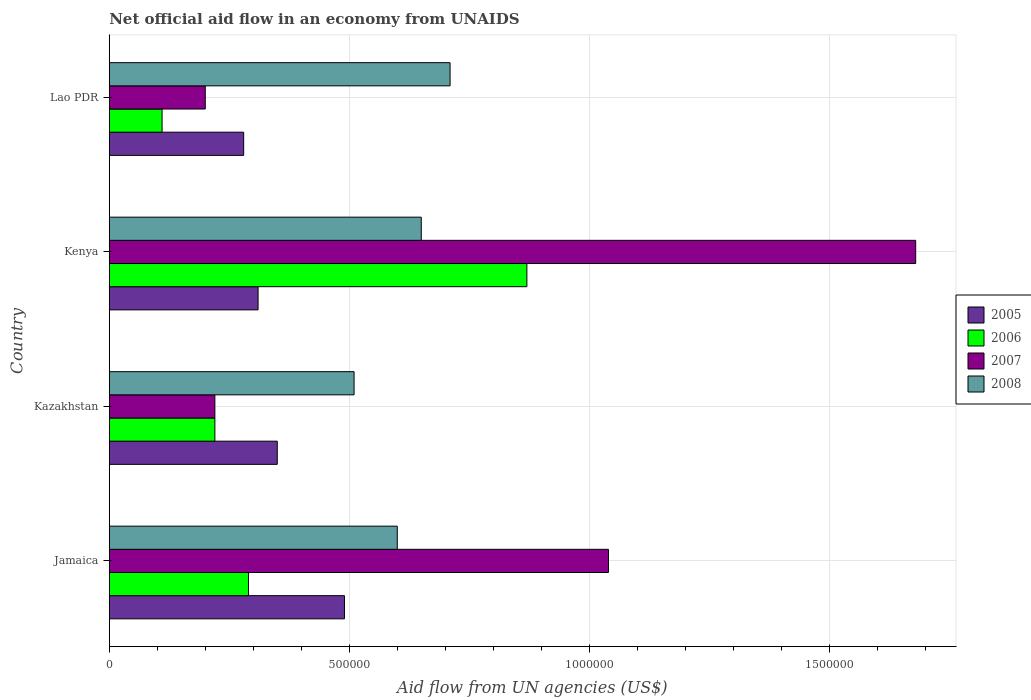What is the label of the 3rd group of bars from the top?
Your answer should be compact. Kazakhstan. In how many cases, is the number of bars for a given country not equal to the number of legend labels?
Make the answer very short. 0. What is the net official aid flow in 2005 in Kazakhstan?
Offer a terse response. 3.50e+05. Across all countries, what is the maximum net official aid flow in 2006?
Your answer should be very brief. 8.70e+05. In which country was the net official aid flow in 2005 maximum?
Your answer should be compact. Jamaica. In which country was the net official aid flow in 2007 minimum?
Provide a succinct answer. Lao PDR. What is the total net official aid flow in 2006 in the graph?
Give a very brief answer. 1.49e+06. What is the difference between the net official aid flow in 2005 in Kazakhstan and the net official aid flow in 2008 in Lao PDR?
Your answer should be compact. -3.60e+05. What is the average net official aid flow in 2005 per country?
Your response must be concise. 3.58e+05. What is the ratio of the net official aid flow in 2006 in Kenya to that in Lao PDR?
Provide a short and direct response. 7.91. What is the difference between the highest and the lowest net official aid flow in 2006?
Make the answer very short. 7.60e+05. In how many countries, is the net official aid flow in 2007 greater than the average net official aid flow in 2007 taken over all countries?
Make the answer very short. 2. Is it the case that in every country, the sum of the net official aid flow in 2006 and net official aid flow in 2007 is greater than the sum of net official aid flow in 2005 and net official aid flow in 2008?
Provide a succinct answer. No. Is it the case that in every country, the sum of the net official aid flow in 2007 and net official aid flow in 2005 is greater than the net official aid flow in 2008?
Offer a terse response. No. Does the graph contain any zero values?
Your answer should be compact. No. Where does the legend appear in the graph?
Ensure brevity in your answer.  Center right. How many legend labels are there?
Provide a short and direct response. 4. What is the title of the graph?
Give a very brief answer. Net official aid flow in an economy from UNAIDS. Does "1975" appear as one of the legend labels in the graph?
Make the answer very short. No. What is the label or title of the X-axis?
Offer a terse response. Aid flow from UN agencies (US$). What is the Aid flow from UN agencies (US$) of 2006 in Jamaica?
Your answer should be very brief. 2.90e+05. What is the Aid flow from UN agencies (US$) in 2007 in Jamaica?
Offer a very short reply. 1.04e+06. What is the Aid flow from UN agencies (US$) of 2008 in Jamaica?
Your answer should be compact. 6.00e+05. What is the Aid flow from UN agencies (US$) in 2005 in Kazakhstan?
Offer a terse response. 3.50e+05. What is the Aid flow from UN agencies (US$) in 2007 in Kazakhstan?
Offer a terse response. 2.20e+05. What is the Aid flow from UN agencies (US$) in 2008 in Kazakhstan?
Your answer should be very brief. 5.10e+05. What is the Aid flow from UN agencies (US$) in 2006 in Kenya?
Ensure brevity in your answer.  8.70e+05. What is the Aid flow from UN agencies (US$) in 2007 in Kenya?
Give a very brief answer. 1.68e+06. What is the Aid flow from UN agencies (US$) of 2008 in Kenya?
Your response must be concise. 6.50e+05. What is the Aid flow from UN agencies (US$) of 2007 in Lao PDR?
Offer a very short reply. 2.00e+05. What is the Aid flow from UN agencies (US$) in 2008 in Lao PDR?
Give a very brief answer. 7.10e+05. Across all countries, what is the maximum Aid flow from UN agencies (US$) of 2005?
Give a very brief answer. 4.90e+05. Across all countries, what is the maximum Aid flow from UN agencies (US$) of 2006?
Give a very brief answer. 8.70e+05. Across all countries, what is the maximum Aid flow from UN agencies (US$) in 2007?
Keep it short and to the point. 1.68e+06. Across all countries, what is the maximum Aid flow from UN agencies (US$) of 2008?
Give a very brief answer. 7.10e+05. Across all countries, what is the minimum Aid flow from UN agencies (US$) of 2005?
Make the answer very short. 2.80e+05. Across all countries, what is the minimum Aid flow from UN agencies (US$) of 2007?
Make the answer very short. 2.00e+05. Across all countries, what is the minimum Aid flow from UN agencies (US$) of 2008?
Your answer should be compact. 5.10e+05. What is the total Aid flow from UN agencies (US$) of 2005 in the graph?
Your response must be concise. 1.43e+06. What is the total Aid flow from UN agencies (US$) in 2006 in the graph?
Your response must be concise. 1.49e+06. What is the total Aid flow from UN agencies (US$) of 2007 in the graph?
Your answer should be very brief. 3.14e+06. What is the total Aid flow from UN agencies (US$) in 2008 in the graph?
Provide a short and direct response. 2.47e+06. What is the difference between the Aid flow from UN agencies (US$) of 2005 in Jamaica and that in Kazakhstan?
Offer a very short reply. 1.40e+05. What is the difference between the Aid flow from UN agencies (US$) in 2006 in Jamaica and that in Kazakhstan?
Ensure brevity in your answer.  7.00e+04. What is the difference between the Aid flow from UN agencies (US$) of 2007 in Jamaica and that in Kazakhstan?
Offer a very short reply. 8.20e+05. What is the difference between the Aid flow from UN agencies (US$) in 2008 in Jamaica and that in Kazakhstan?
Your answer should be compact. 9.00e+04. What is the difference between the Aid flow from UN agencies (US$) of 2005 in Jamaica and that in Kenya?
Provide a short and direct response. 1.80e+05. What is the difference between the Aid flow from UN agencies (US$) in 2006 in Jamaica and that in Kenya?
Offer a terse response. -5.80e+05. What is the difference between the Aid flow from UN agencies (US$) in 2007 in Jamaica and that in Kenya?
Give a very brief answer. -6.40e+05. What is the difference between the Aid flow from UN agencies (US$) of 2008 in Jamaica and that in Kenya?
Your answer should be compact. -5.00e+04. What is the difference between the Aid flow from UN agencies (US$) in 2005 in Jamaica and that in Lao PDR?
Ensure brevity in your answer.  2.10e+05. What is the difference between the Aid flow from UN agencies (US$) of 2006 in Jamaica and that in Lao PDR?
Provide a short and direct response. 1.80e+05. What is the difference between the Aid flow from UN agencies (US$) in 2007 in Jamaica and that in Lao PDR?
Provide a short and direct response. 8.40e+05. What is the difference between the Aid flow from UN agencies (US$) of 2008 in Jamaica and that in Lao PDR?
Provide a succinct answer. -1.10e+05. What is the difference between the Aid flow from UN agencies (US$) of 2006 in Kazakhstan and that in Kenya?
Make the answer very short. -6.50e+05. What is the difference between the Aid flow from UN agencies (US$) in 2007 in Kazakhstan and that in Kenya?
Provide a short and direct response. -1.46e+06. What is the difference between the Aid flow from UN agencies (US$) in 2008 in Kazakhstan and that in Kenya?
Offer a terse response. -1.40e+05. What is the difference between the Aid flow from UN agencies (US$) of 2006 in Kazakhstan and that in Lao PDR?
Provide a short and direct response. 1.10e+05. What is the difference between the Aid flow from UN agencies (US$) in 2007 in Kazakhstan and that in Lao PDR?
Give a very brief answer. 2.00e+04. What is the difference between the Aid flow from UN agencies (US$) in 2008 in Kazakhstan and that in Lao PDR?
Offer a terse response. -2.00e+05. What is the difference between the Aid flow from UN agencies (US$) of 2006 in Kenya and that in Lao PDR?
Your answer should be very brief. 7.60e+05. What is the difference between the Aid flow from UN agencies (US$) of 2007 in Kenya and that in Lao PDR?
Offer a terse response. 1.48e+06. What is the difference between the Aid flow from UN agencies (US$) of 2005 in Jamaica and the Aid flow from UN agencies (US$) of 2006 in Kazakhstan?
Offer a terse response. 2.70e+05. What is the difference between the Aid flow from UN agencies (US$) of 2005 in Jamaica and the Aid flow from UN agencies (US$) of 2007 in Kazakhstan?
Offer a terse response. 2.70e+05. What is the difference between the Aid flow from UN agencies (US$) of 2005 in Jamaica and the Aid flow from UN agencies (US$) of 2008 in Kazakhstan?
Provide a succinct answer. -2.00e+04. What is the difference between the Aid flow from UN agencies (US$) in 2006 in Jamaica and the Aid flow from UN agencies (US$) in 2008 in Kazakhstan?
Your response must be concise. -2.20e+05. What is the difference between the Aid flow from UN agencies (US$) in 2007 in Jamaica and the Aid flow from UN agencies (US$) in 2008 in Kazakhstan?
Offer a terse response. 5.30e+05. What is the difference between the Aid flow from UN agencies (US$) in 2005 in Jamaica and the Aid flow from UN agencies (US$) in 2006 in Kenya?
Provide a short and direct response. -3.80e+05. What is the difference between the Aid flow from UN agencies (US$) of 2005 in Jamaica and the Aid flow from UN agencies (US$) of 2007 in Kenya?
Your answer should be very brief. -1.19e+06. What is the difference between the Aid flow from UN agencies (US$) of 2005 in Jamaica and the Aid flow from UN agencies (US$) of 2008 in Kenya?
Make the answer very short. -1.60e+05. What is the difference between the Aid flow from UN agencies (US$) in 2006 in Jamaica and the Aid flow from UN agencies (US$) in 2007 in Kenya?
Your response must be concise. -1.39e+06. What is the difference between the Aid flow from UN agencies (US$) of 2006 in Jamaica and the Aid flow from UN agencies (US$) of 2008 in Kenya?
Offer a terse response. -3.60e+05. What is the difference between the Aid flow from UN agencies (US$) in 2007 in Jamaica and the Aid flow from UN agencies (US$) in 2008 in Kenya?
Ensure brevity in your answer.  3.90e+05. What is the difference between the Aid flow from UN agencies (US$) in 2005 in Jamaica and the Aid flow from UN agencies (US$) in 2006 in Lao PDR?
Provide a short and direct response. 3.80e+05. What is the difference between the Aid flow from UN agencies (US$) in 2005 in Jamaica and the Aid flow from UN agencies (US$) in 2008 in Lao PDR?
Your answer should be compact. -2.20e+05. What is the difference between the Aid flow from UN agencies (US$) in 2006 in Jamaica and the Aid flow from UN agencies (US$) in 2008 in Lao PDR?
Make the answer very short. -4.20e+05. What is the difference between the Aid flow from UN agencies (US$) in 2005 in Kazakhstan and the Aid flow from UN agencies (US$) in 2006 in Kenya?
Offer a very short reply. -5.20e+05. What is the difference between the Aid flow from UN agencies (US$) of 2005 in Kazakhstan and the Aid flow from UN agencies (US$) of 2007 in Kenya?
Your answer should be compact. -1.33e+06. What is the difference between the Aid flow from UN agencies (US$) in 2005 in Kazakhstan and the Aid flow from UN agencies (US$) in 2008 in Kenya?
Provide a short and direct response. -3.00e+05. What is the difference between the Aid flow from UN agencies (US$) in 2006 in Kazakhstan and the Aid flow from UN agencies (US$) in 2007 in Kenya?
Keep it short and to the point. -1.46e+06. What is the difference between the Aid flow from UN agencies (US$) in 2006 in Kazakhstan and the Aid flow from UN agencies (US$) in 2008 in Kenya?
Give a very brief answer. -4.30e+05. What is the difference between the Aid flow from UN agencies (US$) of 2007 in Kazakhstan and the Aid flow from UN agencies (US$) of 2008 in Kenya?
Offer a very short reply. -4.30e+05. What is the difference between the Aid flow from UN agencies (US$) of 2005 in Kazakhstan and the Aid flow from UN agencies (US$) of 2006 in Lao PDR?
Provide a short and direct response. 2.40e+05. What is the difference between the Aid flow from UN agencies (US$) in 2005 in Kazakhstan and the Aid flow from UN agencies (US$) in 2007 in Lao PDR?
Your response must be concise. 1.50e+05. What is the difference between the Aid flow from UN agencies (US$) in 2005 in Kazakhstan and the Aid flow from UN agencies (US$) in 2008 in Lao PDR?
Provide a succinct answer. -3.60e+05. What is the difference between the Aid flow from UN agencies (US$) of 2006 in Kazakhstan and the Aid flow from UN agencies (US$) of 2008 in Lao PDR?
Keep it short and to the point. -4.90e+05. What is the difference between the Aid flow from UN agencies (US$) of 2007 in Kazakhstan and the Aid flow from UN agencies (US$) of 2008 in Lao PDR?
Your answer should be very brief. -4.90e+05. What is the difference between the Aid flow from UN agencies (US$) of 2005 in Kenya and the Aid flow from UN agencies (US$) of 2006 in Lao PDR?
Your answer should be compact. 2.00e+05. What is the difference between the Aid flow from UN agencies (US$) of 2005 in Kenya and the Aid flow from UN agencies (US$) of 2007 in Lao PDR?
Offer a terse response. 1.10e+05. What is the difference between the Aid flow from UN agencies (US$) in 2005 in Kenya and the Aid flow from UN agencies (US$) in 2008 in Lao PDR?
Ensure brevity in your answer.  -4.00e+05. What is the difference between the Aid flow from UN agencies (US$) in 2006 in Kenya and the Aid flow from UN agencies (US$) in 2007 in Lao PDR?
Your response must be concise. 6.70e+05. What is the difference between the Aid flow from UN agencies (US$) in 2006 in Kenya and the Aid flow from UN agencies (US$) in 2008 in Lao PDR?
Offer a terse response. 1.60e+05. What is the difference between the Aid flow from UN agencies (US$) of 2007 in Kenya and the Aid flow from UN agencies (US$) of 2008 in Lao PDR?
Offer a very short reply. 9.70e+05. What is the average Aid flow from UN agencies (US$) of 2005 per country?
Offer a very short reply. 3.58e+05. What is the average Aid flow from UN agencies (US$) in 2006 per country?
Offer a very short reply. 3.72e+05. What is the average Aid flow from UN agencies (US$) in 2007 per country?
Give a very brief answer. 7.85e+05. What is the average Aid flow from UN agencies (US$) of 2008 per country?
Offer a terse response. 6.18e+05. What is the difference between the Aid flow from UN agencies (US$) in 2005 and Aid flow from UN agencies (US$) in 2006 in Jamaica?
Your response must be concise. 2.00e+05. What is the difference between the Aid flow from UN agencies (US$) in 2005 and Aid flow from UN agencies (US$) in 2007 in Jamaica?
Provide a succinct answer. -5.50e+05. What is the difference between the Aid flow from UN agencies (US$) in 2006 and Aid flow from UN agencies (US$) in 2007 in Jamaica?
Provide a short and direct response. -7.50e+05. What is the difference between the Aid flow from UN agencies (US$) of 2006 and Aid flow from UN agencies (US$) of 2008 in Jamaica?
Provide a short and direct response. -3.10e+05. What is the difference between the Aid flow from UN agencies (US$) of 2006 and Aid flow from UN agencies (US$) of 2007 in Kazakhstan?
Ensure brevity in your answer.  0. What is the difference between the Aid flow from UN agencies (US$) in 2006 and Aid flow from UN agencies (US$) in 2008 in Kazakhstan?
Offer a very short reply. -2.90e+05. What is the difference between the Aid flow from UN agencies (US$) of 2007 and Aid flow from UN agencies (US$) of 2008 in Kazakhstan?
Your answer should be compact. -2.90e+05. What is the difference between the Aid flow from UN agencies (US$) in 2005 and Aid flow from UN agencies (US$) in 2006 in Kenya?
Give a very brief answer. -5.60e+05. What is the difference between the Aid flow from UN agencies (US$) of 2005 and Aid flow from UN agencies (US$) of 2007 in Kenya?
Your response must be concise. -1.37e+06. What is the difference between the Aid flow from UN agencies (US$) in 2006 and Aid flow from UN agencies (US$) in 2007 in Kenya?
Provide a short and direct response. -8.10e+05. What is the difference between the Aid flow from UN agencies (US$) in 2006 and Aid flow from UN agencies (US$) in 2008 in Kenya?
Your answer should be very brief. 2.20e+05. What is the difference between the Aid flow from UN agencies (US$) in 2007 and Aid flow from UN agencies (US$) in 2008 in Kenya?
Your answer should be very brief. 1.03e+06. What is the difference between the Aid flow from UN agencies (US$) of 2005 and Aid flow from UN agencies (US$) of 2006 in Lao PDR?
Your answer should be very brief. 1.70e+05. What is the difference between the Aid flow from UN agencies (US$) in 2005 and Aid flow from UN agencies (US$) in 2008 in Lao PDR?
Keep it short and to the point. -4.30e+05. What is the difference between the Aid flow from UN agencies (US$) in 2006 and Aid flow from UN agencies (US$) in 2007 in Lao PDR?
Keep it short and to the point. -9.00e+04. What is the difference between the Aid flow from UN agencies (US$) of 2006 and Aid flow from UN agencies (US$) of 2008 in Lao PDR?
Provide a short and direct response. -6.00e+05. What is the difference between the Aid flow from UN agencies (US$) of 2007 and Aid flow from UN agencies (US$) of 2008 in Lao PDR?
Your response must be concise. -5.10e+05. What is the ratio of the Aid flow from UN agencies (US$) of 2006 in Jamaica to that in Kazakhstan?
Keep it short and to the point. 1.32. What is the ratio of the Aid flow from UN agencies (US$) in 2007 in Jamaica to that in Kazakhstan?
Provide a succinct answer. 4.73. What is the ratio of the Aid flow from UN agencies (US$) of 2008 in Jamaica to that in Kazakhstan?
Make the answer very short. 1.18. What is the ratio of the Aid flow from UN agencies (US$) of 2005 in Jamaica to that in Kenya?
Offer a very short reply. 1.58. What is the ratio of the Aid flow from UN agencies (US$) in 2007 in Jamaica to that in Kenya?
Your response must be concise. 0.62. What is the ratio of the Aid flow from UN agencies (US$) in 2005 in Jamaica to that in Lao PDR?
Provide a short and direct response. 1.75. What is the ratio of the Aid flow from UN agencies (US$) of 2006 in Jamaica to that in Lao PDR?
Your answer should be very brief. 2.64. What is the ratio of the Aid flow from UN agencies (US$) of 2008 in Jamaica to that in Lao PDR?
Offer a very short reply. 0.85. What is the ratio of the Aid flow from UN agencies (US$) in 2005 in Kazakhstan to that in Kenya?
Offer a very short reply. 1.13. What is the ratio of the Aid flow from UN agencies (US$) of 2006 in Kazakhstan to that in Kenya?
Keep it short and to the point. 0.25. What is the ratio of the Aid flow from UN agencies (US$) in 2007 in Kazakhstan to that in Kenya?
Ensure brevity in your answer.  0.13. What is the ratio of the Aid flow from UN agencies (US$) in 2008 in Kazakhstan to that in Kenya?
Your answer should be very brief. 0.78. What is the ratio of the Aid flow from UN agencies (US$) of 2006 in Kazakhstan to that in Lao PDR?
Give a very brief answer. 2. What is the ratio of the Aid flow from UN agencies (US$) in 2007 in Kazakhstan to that in Lao PDR?
Your response must be concise. 1.1. What is the ratio of the Aid flow from UN agencies (US$) of 2008 in Kazakhstan to that in Lao PDR?
Offer a terse response. 0.72. What is the ratio of the Aid flow from UN agencies (US$) of 2005 in Kenya to that in Lao PDR?
Offer a very short reply. 1.11. What is the ratio of the Aid flow from UN agencies (US$) of 2006 in Kenya to that in Lao PDR?
Your answer should be very brief. 7.91. What is the ratio of the Aid flow from UN agencies (US$) of 2007 in Kenya to that in Lao PDR?
Your answer should be compact. 8.4. What is the ratio of the Aid flow from UN agencies (US$) in 2008 in Kenya to that in Lao PDR?
Offer a terse response. 0.92. What is the difference between the highest and the second highest Aid flow from UN agencies (US$) in 2005?
Make the answer very short. 1.40e+05. What is the difference between the highest and the second highest Aid flow from UN agencies (US$) in 2006?
Provide a short and direct response. 5.80e+05. What is the difference between the highest and the second highest Aid flow from UN agencies (US$) in 2007?
Give a very brief answer. 6.40e+05. What is the difference between the highest and the second highest Aid flow from UN agencies (US$) of 2008?
Your answer should be very brief. 6.00e+04. What is the difference between the highest and the lowest Aid flow from UN agencies (US$) of 2006?
Your response must be concise. 7.60e+05. What is the difference between the highest and the lowest Aid flow from UN agencies (US$) in 2007?
Your answer should be very brief. 1.48e+06. 